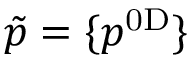<formula> <loc_0><loc_0><loc_500><loc_500>\tilde { p } = \{ p ^ { 0 D } \}</formula> 